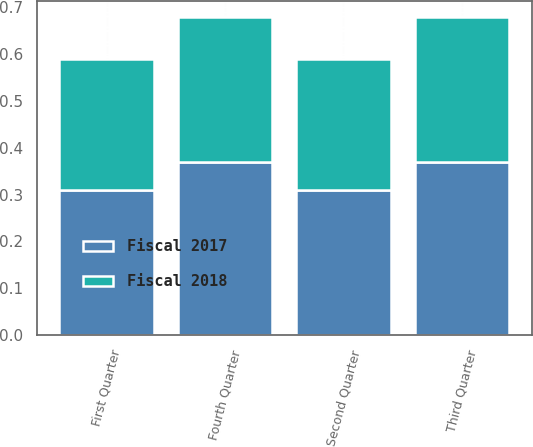Convert chart to OTSL. <chart><loc_0><loc_0><loc_500><loc_500><stacked_bar_chart><ecel><fcel>Fourth Quarter<fcel>Third Quarter<fcel>Second Quarter<fcel>First Quarter<nl><fcel>Fiscal 2017<fcel>0.37<fcel>0.37<fcel>0.31<fcel>0.31<nl><fcel>Fiscal 2018<fcel>0.31<fcel>0.31<fcel>0.28<fcel>0.28<nl></chart> 